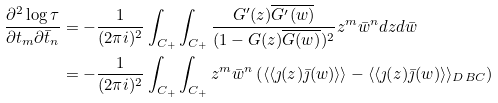Convert formula to latex. <formula><loc_0><loc_0><loc_500><loc_500>\frac { \partial ^ { 2 } \log \tau } { \partial t _ { m } \partial \bar { t } _ { n } } & = - \frac { 1 } { ( 2 \pi i ) ^ { 2 } } \int _ { C _ { + } } \int _ { C _ { + } } \frac { G ^ { \prime } ( z ) \overline { G ^ { \prime } ( w ) } } { ( 1 - G ( z ) \overline { G ( w ) } ) ^ { 2 } } z ^ { m } \bar { w } ^ { n } d z d \bar { w } \\ & = - \frac { 1 } { ( 2 \pi i ) ^ { 2 } } \int _ { C _ { + } } \int _ { C _ { + } } z ^ { m } \bar { w } ^ { n } \left ( \langle \langle \jmath ( z ) \bar { \jmath } ( w ) \rangle \rangle - \langle \langle \jmath ( z ) \bar { \jmath } ( w ) \rangle \rangle _ { D B C } \right )</formula> 